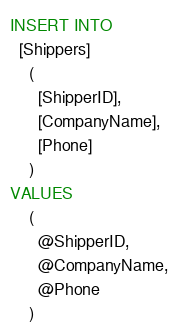Convert code to text. <code><loc_0><loc_0><loc_500><loc_500><_SQL_>INSERT INTO 
  [Shippers]
    (
      [ShipperID],
      [CompanyName],
      [Phone]
    )
VALUES
    (
      @ShipperID,
      @CompanyName,
      @Phone
    )
</code> 